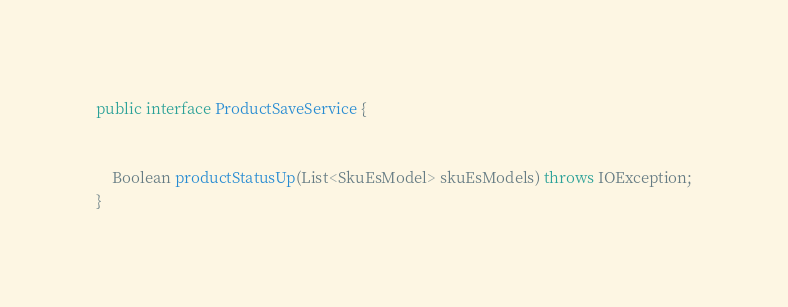Convert code to text. <code><loc_0><loc_0><loc_500><loc_500><_Java_>
public interface ProductSaveService {


    Boolean productStatusUp(List<SkuEsModel> skuEsModels) throws IOException;
}
</code> 